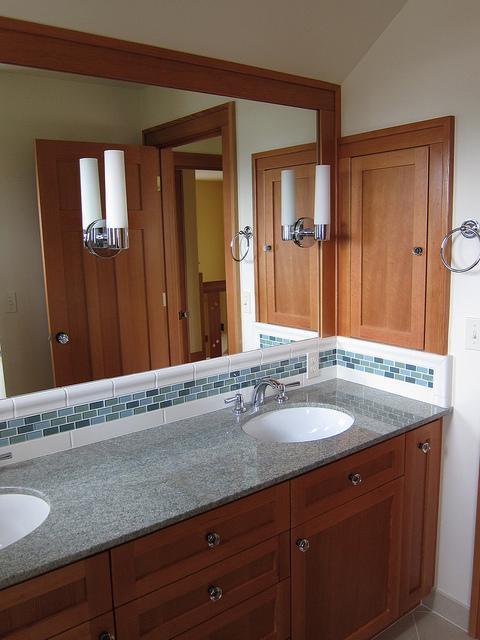How many sinks are in this image?
Give a very brief answer. 2. How many sinks are visible?
Give a very brief answer. 2. 